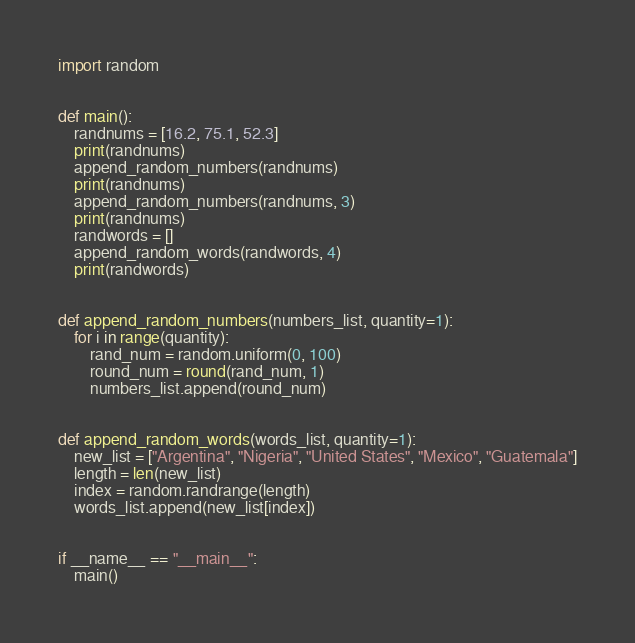<code> <loc_0><loc_0><loc_500><loc_500><_Python_>import random


def main():
    randnums = [16.2, 75.1, 52.3]
    print(randnums)
    append_random_numbers(randnums)
    print(randnums)
    append_random_numbers(randnums, 3)
    print(randnums)
    randwords = []
    append_random_words(randwords, 4)
    print(randwords)


def append_random_numbers(numbers_list, quantity=1):
    for i in range(quantity):
        rand_num = random.uniform(0, 100)
        round_num = round(rand_num, 1)
        numbers_list.append(round_num)


def append_random_words(words_list, quantity=1):
    new_list = ["Argentina", "Nigeria", "United States", "Mexico", "Guatemala"]
    length = len(new_list)
    index = random.randrange(length)
    words_list.append(new_list[index])


if __name__ == "__main__":
    main()
</code> 